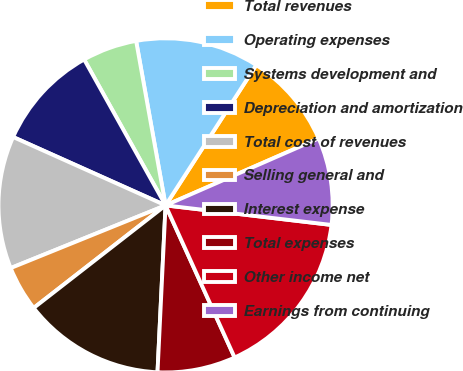Convert chart to OTSL. <chart><loc_0><loc_0><loc_500><loc_500><pie_chart><fcel>Total revenues<fcel>Operating expenses<fcel>Systems development and<fcel>Depreciation and amortization<fcel>Total cost of revenues<fcel>Selling general and<fcel>Interest expense<fcel>Total expenses<fcel>Other income net<fcel>Earnings from continuing<nl><fcel>9.31%<fcel>11.95%<fcel>5.28%<fcel>10.19%<fcel>12.83%<fcel>4.4%<fcel>13.71%<fcel>7.55%<fcel>16.35%<fcel>8.43%<nl></chart> 